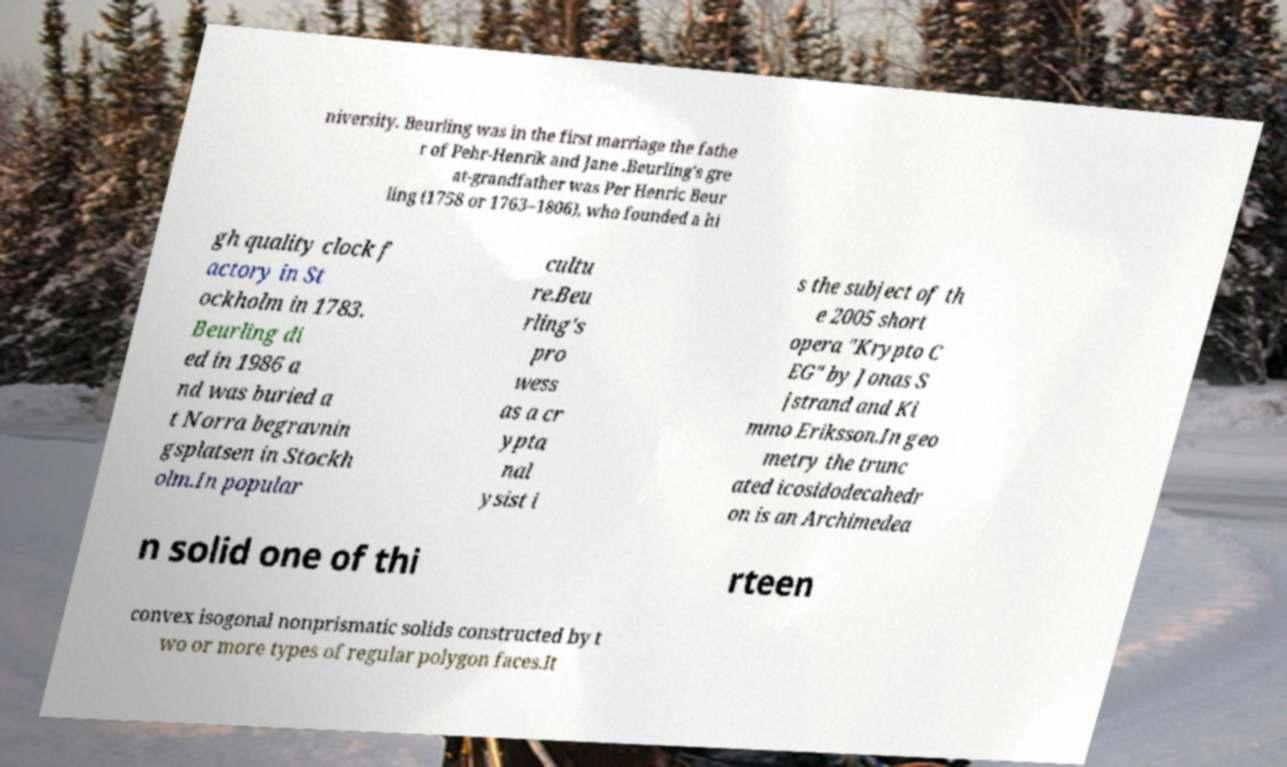I need the written content from this picture converted into text. Can you do that? niversity. Beurling was in the first marriage the fathe r of Pehr-Henrik and Jane .Beurling's gre at-grandfather was Per Henric Beur ling (1758 or 1763–1806), who founded a hi gh quality clock f actory in St ockholm in 1783. Beurling di ed in 1986 a nd was buried a t Norra begravnin gsplatsen in Stockh olm.In popular cultu re.Beu rling's pro wess as a cr ypta nal ysist i s the subject of th e 2005 short opera "Krypto C EG" by Jonas S jstrand and Ki mmo Eriksson.In geo metry the trunc ated icosidodecahedr on is an Archimedea n solid one of thi rteen convex isogonal nonprismatic solids constructed by t wo or more types of regular polygon faces.It 